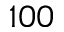<formula> <loc_0><loc_0><loc_500><loc_500>1 0 0</formula> 